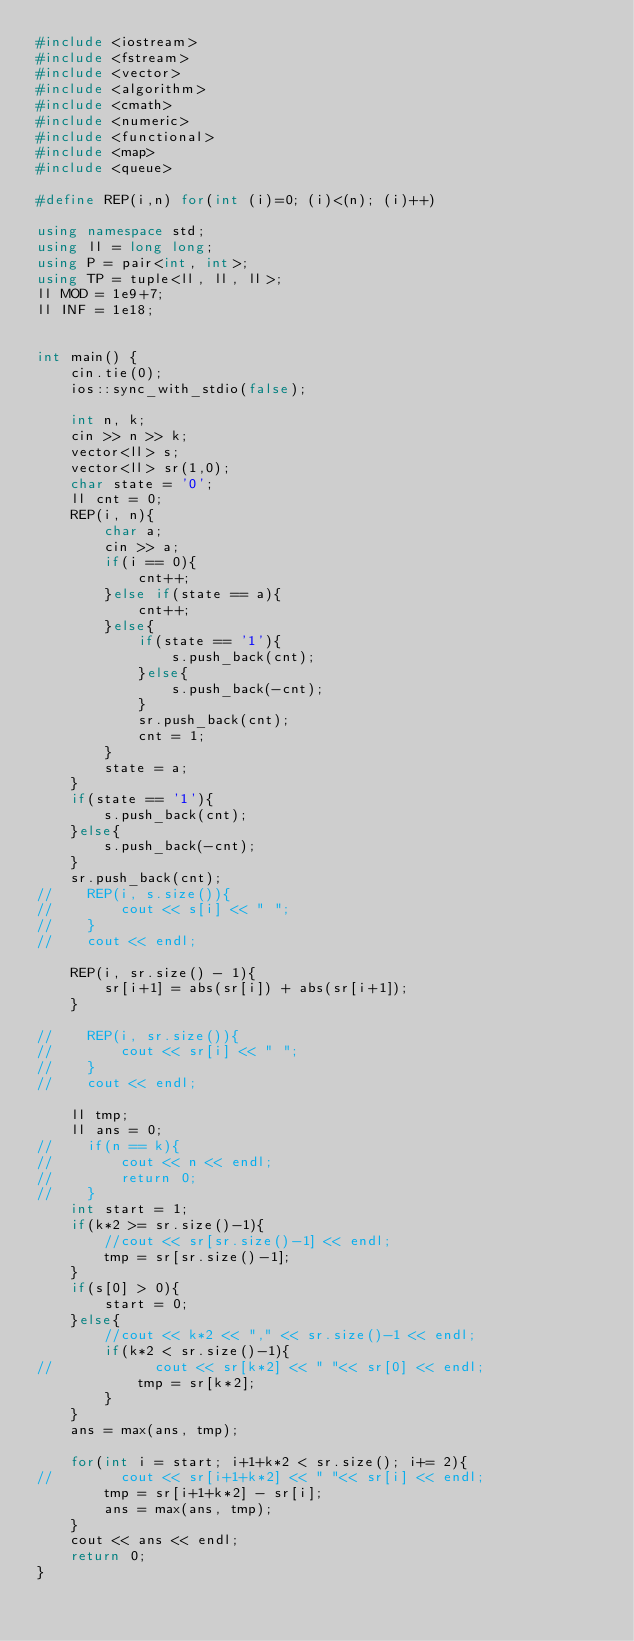Convert code to text. <code><loc_0><loc_0><loc_500><loc_500><_C++_>#include <iostream>
#include <fstream>
#include <vector>
#include <algorithm>
#include <cmath>
#include <numeric>
#include <functional>
#include <map>
#include <queue>

#define REP(i,n) for(int (i)=0; (i)<(n); (i)++)

using namespace std;
using ll = long long;
using P = pair<int, int>;
using TP = tuple<ll, ll, ll>;
ll MOD = 1e9+7;
ll INF = 1e18;


int main() {
    cin.tie(0);
    ios::sync_with_stdio(false);
    
    int n, k;
    cin >> n >> k;
    vector<ll> s;
    vector<ll> sr(1,0);
    char state = '0';
    ll cnt = 0;
    REP(i, n){
        char a;
        cin >> a;
        if(i == 0){
            cnt++;
        }else if(state == a){
            cnt++;
        }else{
            if(state == '1'){
                s.push_back(cnt);
            }else{
                s.push_back(-cnt);
            }
            sr.push_back(cnt);
            cnt = 1;
        }
        state = a;
    }
    if(state == '1'){
        s.push_back(cnt);
    }else{
        s.push_back(-cnt);
    }
    sr.push_back(cnt);
//    REP(i, s.size()){
//        cout << s[i] << " ";
//    }
//    cout << endl;

    REP(i, sr.size() - 1){
        sr[i+1] = abs(sr[i]) + abs(sr[i+1]);
    }

//    REP(i, sr.size()){
//        cout << sr[i] << " ";
//    }
//    cout << endl;

    ll tmp;
    ll ans = 0;
//    if(n == k){
//        cout << n << endl;
//        return 0;
//    }
    int start = 1;
    if(k*2 >= sr.size()-1){
        //cout << sr[sr.size()-1] << endl;
        tmp = sr[sr.size()-1];
    }
    if(s[0] > 0){
        start = 0;
    }else{
        //cout << k*2 << "," << sr.size()-1 << endl;
        if(k*2 < sr.size()-1){
//            cout << sr[k*2] << " "<< sr[0] << endl;
            tmp = sr[k*2];
        }
    }
    ans = max(ans, tmp);

    for(int i = start; i+1+k*2 < sr.size(); i+= 2){
//        cout << sr[i+1+k*2] << " "<< sr[i] << endl;
        tmp = sr[i+1+k*2] - sr[i];
        ans = max(ans, tmp);
    }
    cout << ans << endl;
    return 0;
}
</code> 